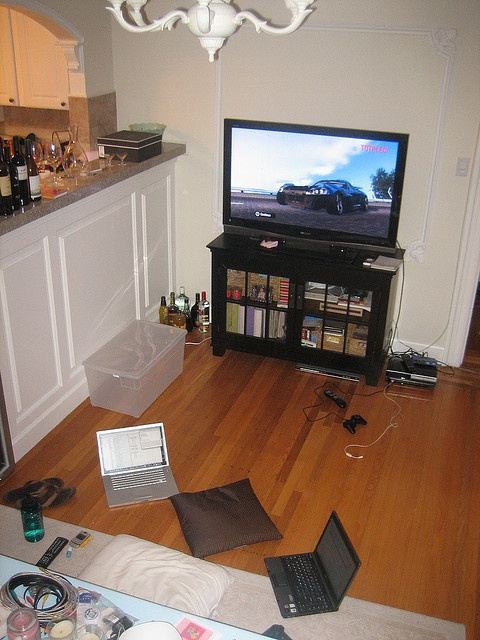Describe the objects in this image and their specific colors. I can see tv in gray, black, and white tones, laptop in gray and black tones, laptop in gray, lightgray, and darkgray tones, vase in gray, brown, and maroon tones, and bottle in gray, black, and darkgray tones in this image. 